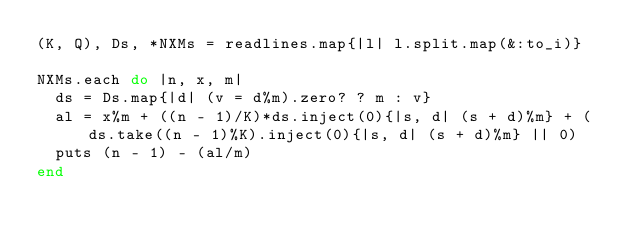Convert code to text. <code><loc_0><loc_0><loc_500><loc_500><_Ruby_>(K, Q), Ds, *NXMs = readlines.map{|l| l.split.map(&:to_i)}

NXMs.each do |n, x, m|
  ds = Ds.map{|d| (v = d%m).zero? ? m : v}
  al = x%m + ((n - 1)/K)*ds.inject(0){|s, d| (s + d)%m} + (ds.take((n - 1)%K).inject(0){|s, d| (s + d)%m} || 0)
  puts (n - 1) - (al/m)
end</code> 